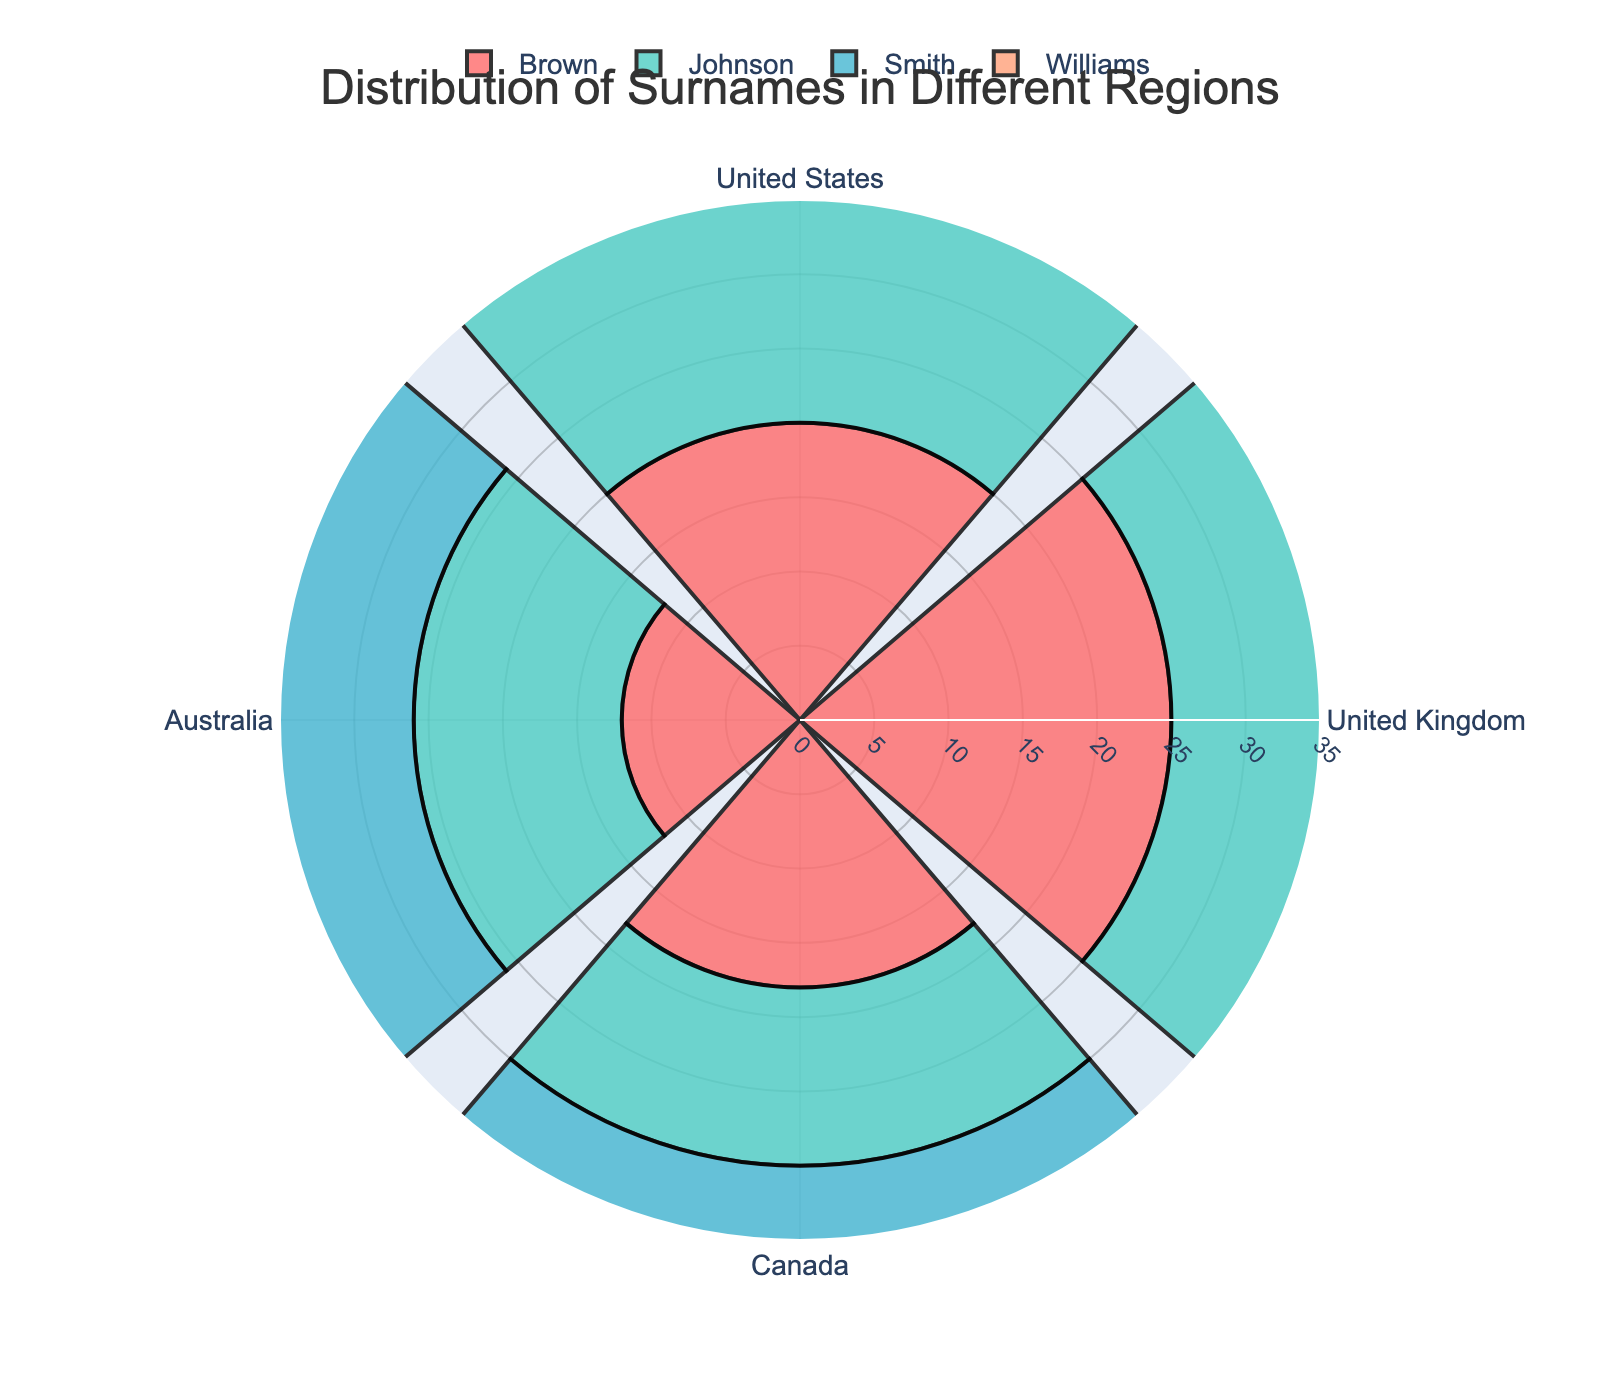What is the title of the figure? The title is typically located at the top of the figure. In this case, it states: "Distribution of Surnames in Different Regions".
Answer: Distribution of Surnames in Different Regions Which surname has the highest percentage in the United Kingdom? By visually inspecting the segments for each surname under the United Kingdom, we see the highest percentage is for "Brown" with 25%.
Answer: Brown How many percentages does the surname "Smith" account for in Australia? By looking at the segment labelled "Smith" in Australia, we find it reports 10%.
Answer: 10% Which region has the highest percentage for the surname "Johnson"? We compare the percentage segments for "Johnson" across different regions and see that the United States has the highest, which is 30%.
Answer: United States Compare the percentage of "Williams" in the United States and the United Kingdom. Which one is higher? By looking at the "Williams" segments in both the United States (28%) and the United Kingdom (22%), it's clear that the United States has a higher percentage.
Answer: United States What's the combined percentage of the surname "Smith" in Canada and Australia? Adding the values for "Smith" in Canada (15%) and Australia (10%) gives 15% + 10% = 25%.
Answer: 25% How does the percentage of "Williams" in Australia compare to "Brown" in Canada? "Williams" in Australia is given as 12%, while "Brown" in Canada is 18%. Therefore, "Brown" in Canada is higher.
Answer: Brown in Canada What is the average percentage of the surname "Johnson" across all regions? Summing the percentages of "Johnson" across the regions (30% + 18% + 12% + 14% = 74%) and dividing by the number of regions (4) results in an average of 74% / 4 = 18.5%.
Answer: 18.5% Which surname appears to have the most even distribution across all regions? By looking at the uniformity of segment sizes for each surname, "Brown" seems to have more balanced percentages across the regions (20%, 25%, 18%, 12%).
Answer: Brown 